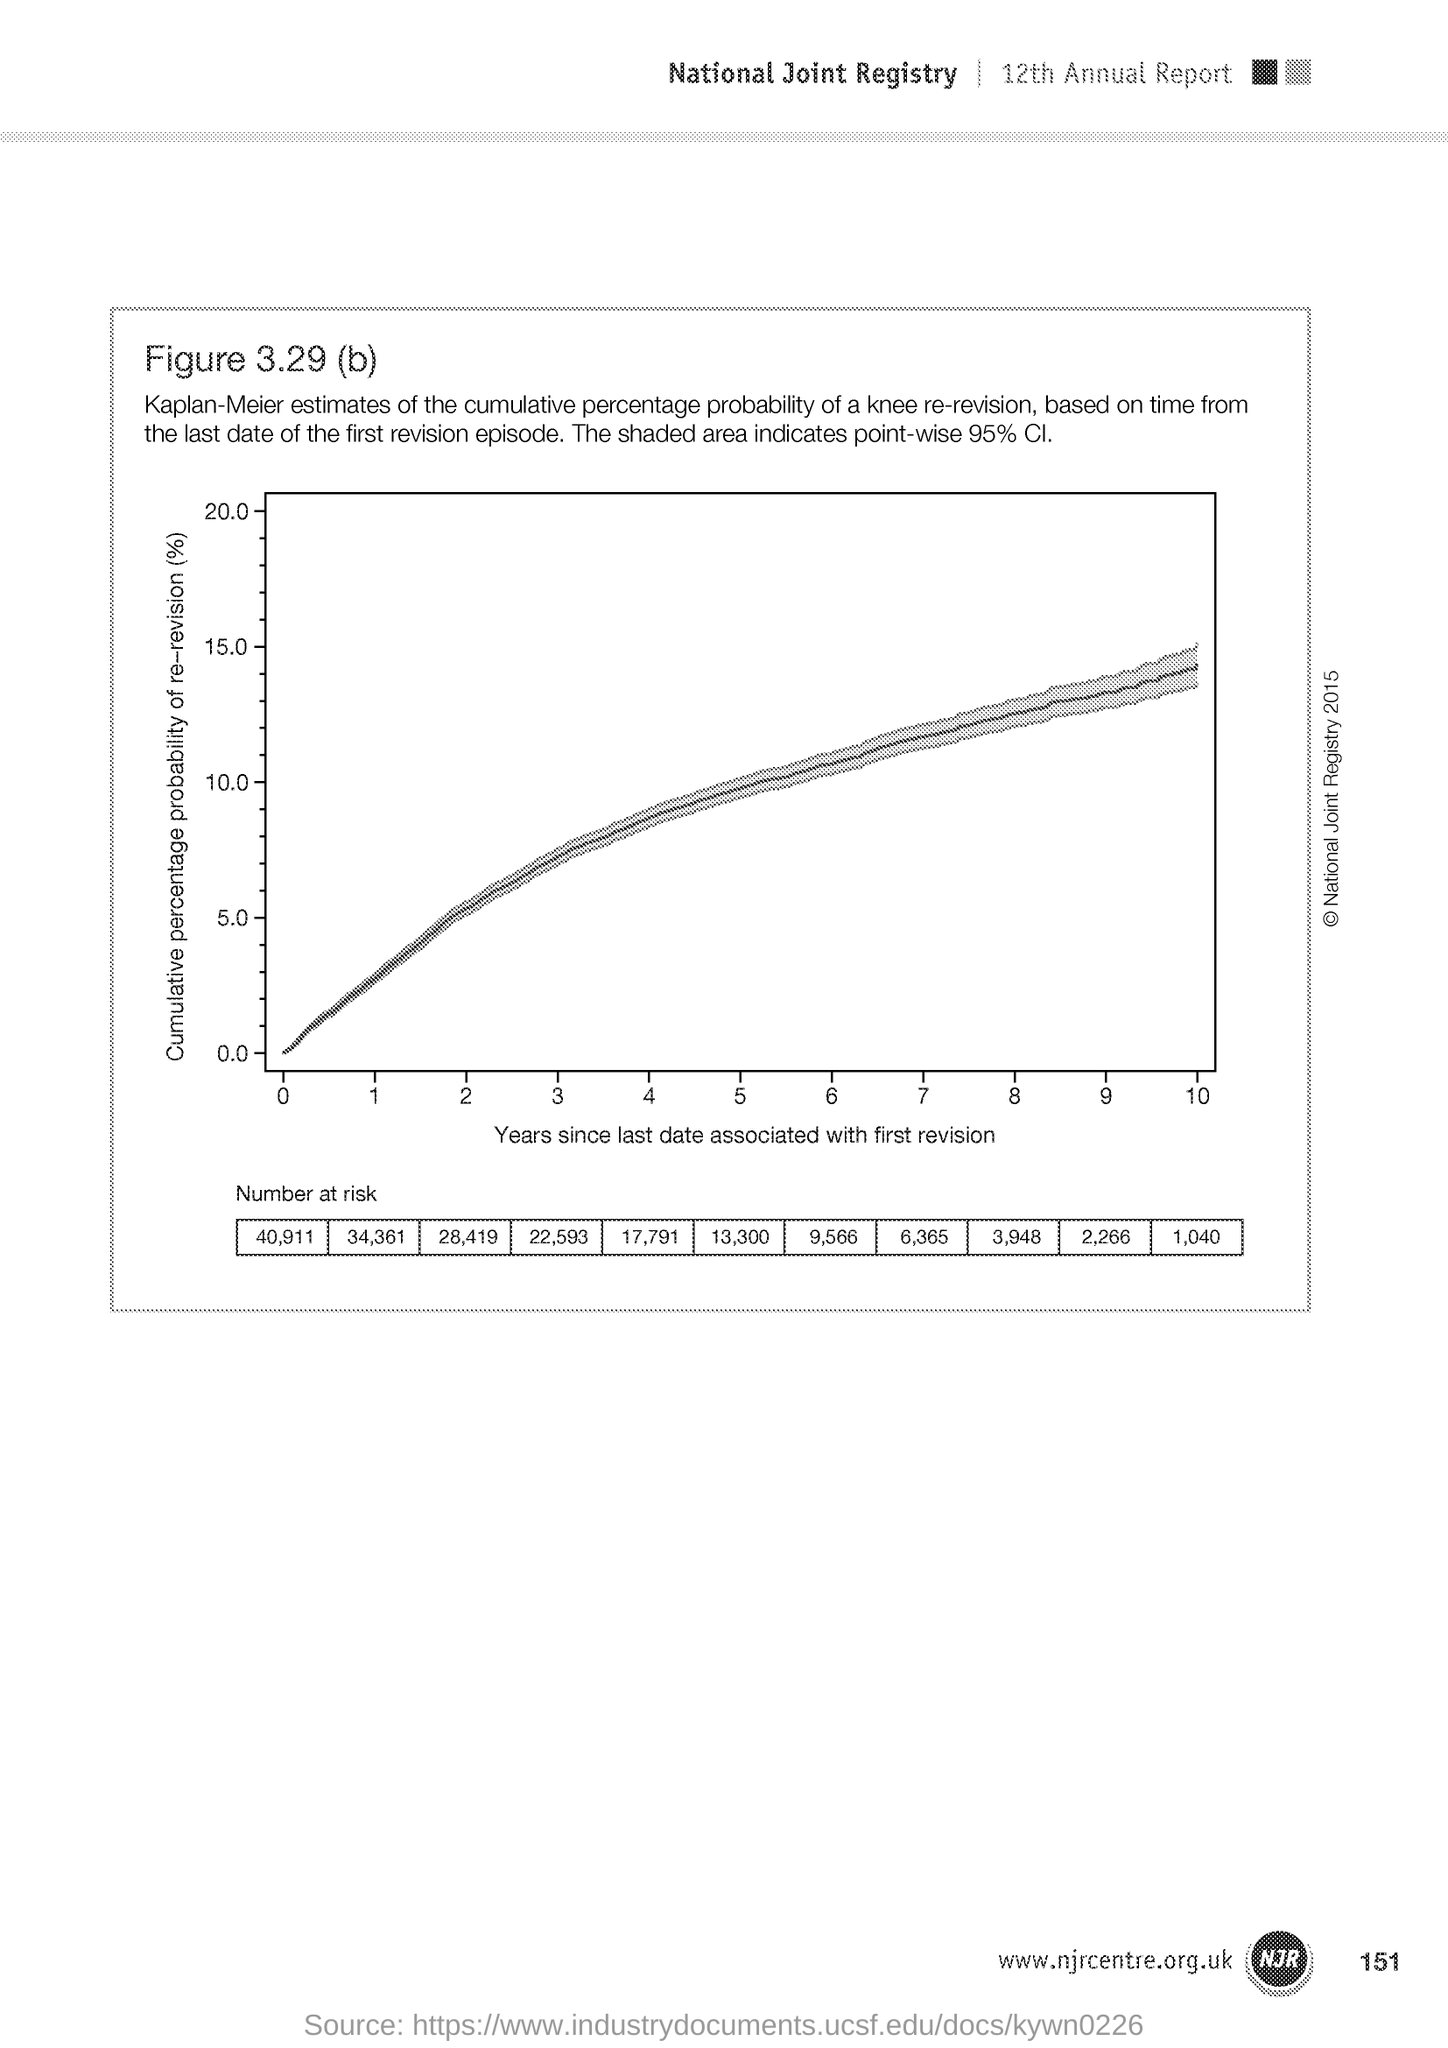What is the page no mentioned in this document?
Ensure brevity in your answer.  151. What does x-axis of the graph represent?
Provide a succinct answer. Years since last date associated with first revision. What does y-axis of the graph represent?
Give a very brief answer. Cumulative percentage probability of re-revision (%). 